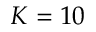<formula> <loc_0><loc_0><loc_500><loc_500>K = 1 0</formula> 